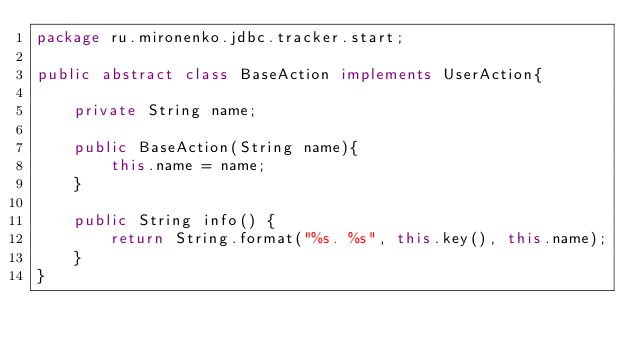Convert code to text. <code><loc_0><loc_0><loc_500><loc_500><_Java_>package ru.mironenko.jdbc.tracker.start;

public abstract class BaseAction implements UserAction{

    private String name;

    public BaseAction(String name){
        this.name = name;
    }

    public String info() {
        return String.format("%s. %s", this.key(), this.name);
    }
}</code> 